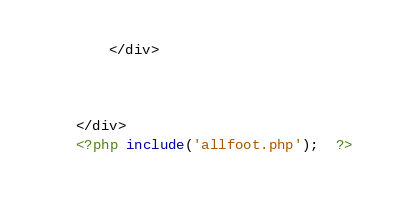Convert code to text. <code><loc_0><loc_0><loc_500><loc_500><_PHP_>
		</div>



	</div>
	<?php include('allfoot.php');  ?></code> 